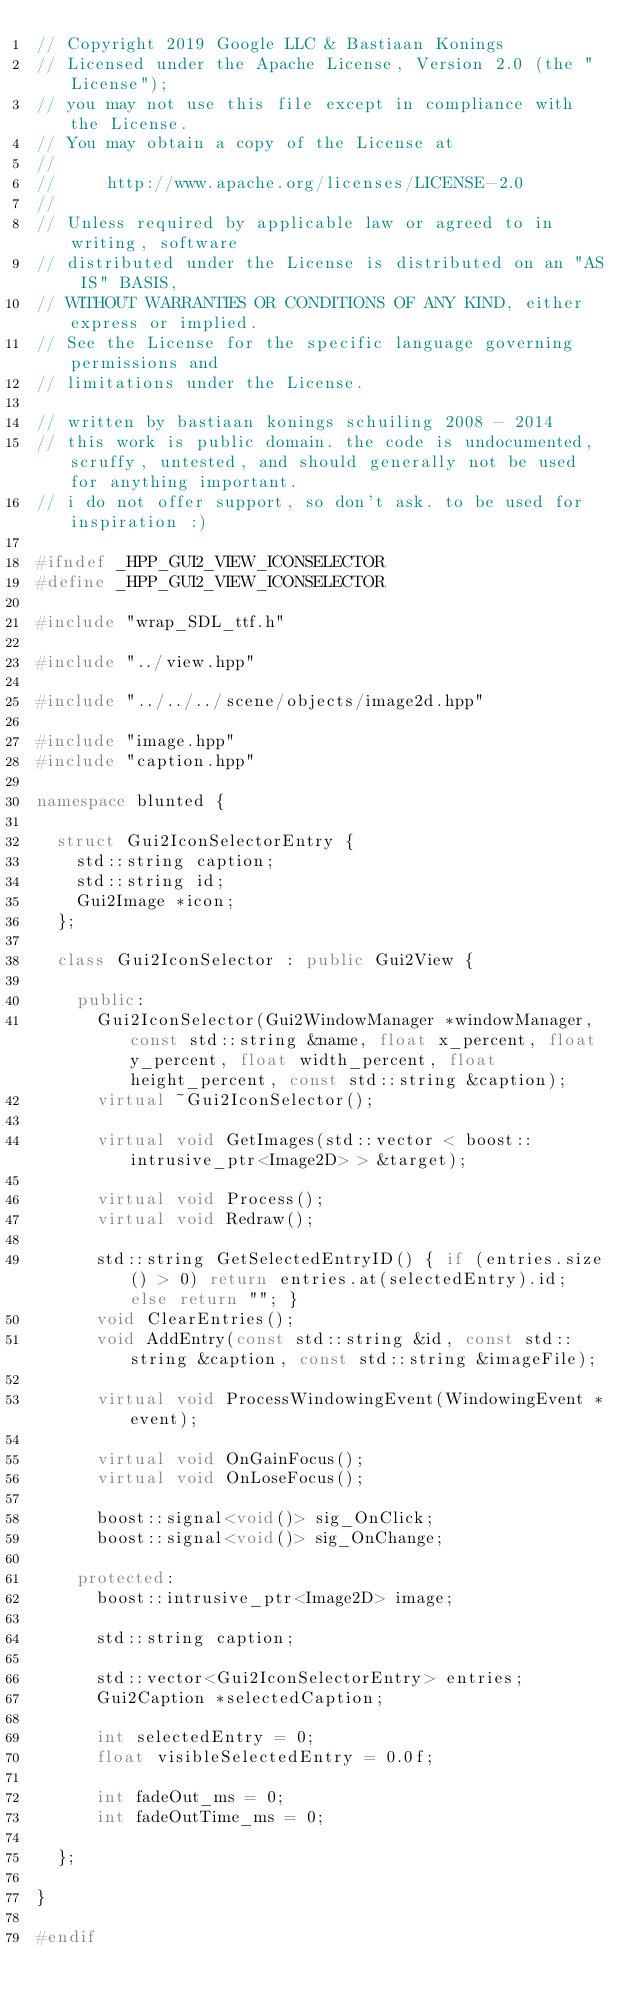Convert code to text. <code><loc_0><loc_0><loc_500><loc_500><_C++_>// Copyright 2019 Google LLC & Bastiaan Konings
// Licensed under the Apache License, Version 2.0 (the "License");
// you may not use this file except in compliance with the License.
// You may obtain a copy of the License at
//
//     http://www.apache.org/licenses/LICENSE-2.0
//
// Unless required by applicable law or agreed to in writing, software
// distributed under the License is distributed on an "AS IS" BASIS,
// WITHOUT WARRANTIES OR CONDITIONS OF ANY KIND, either express or implied.
// See the License for the specific language governing permissions and
// limitations under the License.

// written by bastiaan konings schuiling 2008 - 2014
// this work is public domain. the code is undocumented, scruffy, untested, and should generally not be used for anything important.
// i do not offer support, so don't ask. to be used for inspiration :)

#ifndef _HPP_GUI2_VIEW_ICONSELECTOR
#define _HPP_GUI2_VIEW_ICONSELECTOR

#include "wrap_SDL_ttf.h"

#include "../view.hpp"

#include "../../../scene/objects/image2d.hpp"

#include "image.hpp"
#include "caption.hpp"

namespace blunted {

  struct Gui2IconSelectorEntry {
    std::string caption;
    std::string id;
    Gui2Image *icon;
  };

  class Gui2IconSelector : public Gui2View {

    public:
      Gui2IconSelector(Gui2WindowManager *windowManager, const std::string &name, float x_percent, float y_percent, float width_percent, float height_percent, const std::string &caption);
      virtual ~Gui2IconSelector();

      virtual void GetImages(std::vector < boost::intrusive_ptr<Image2D> > &target);

      virtual void Process();
      virtual void Redraw();

      std::string GetSelectedEntryID() { if (entries.size() > 0) return entries.at(selectedEntry).id; else return ""; }
      void ClearEntries();
      void AddEntry(const std::string &id, const std::string &caption, const std::string &imageFile);

      virtual void ProcessWindowingEvent(WindowingEvent *event);

      virtual void OnGainFocus();
      virtual void OnLoseFocus();

      boost::signal<void()> sig_OnClick;
      boost::signal<void()> sig_OnChange;

    protected:
      boost::intrusive_ptr<Image2D> image;

      std::string caption;

      std::vector<Gui2IconSelectorEntry> entries;
      Gui2Caption *selectedCaption;

      int selectedEntry = 0;
      float visibleSelectedEntry = 0.0f;

      int fadeOut_ms = 0;
      int fadeOutTime_ms = 0;

  };

}

#endif
</code> 